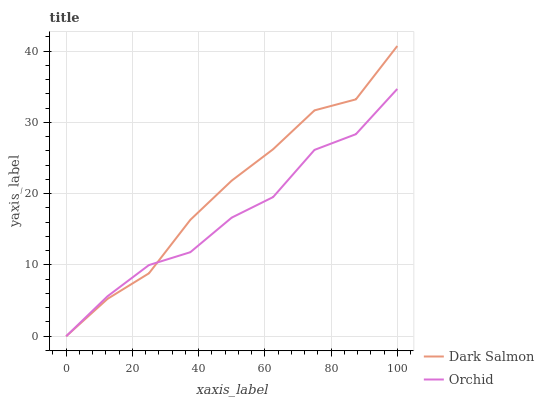Does Orchid have the maximum area under the curve?
Answer yes or no. No. Is Orchid the smoothest?
Answer yes or no. No. Does Orchid have the highest value?
Answer yes or no. No. 